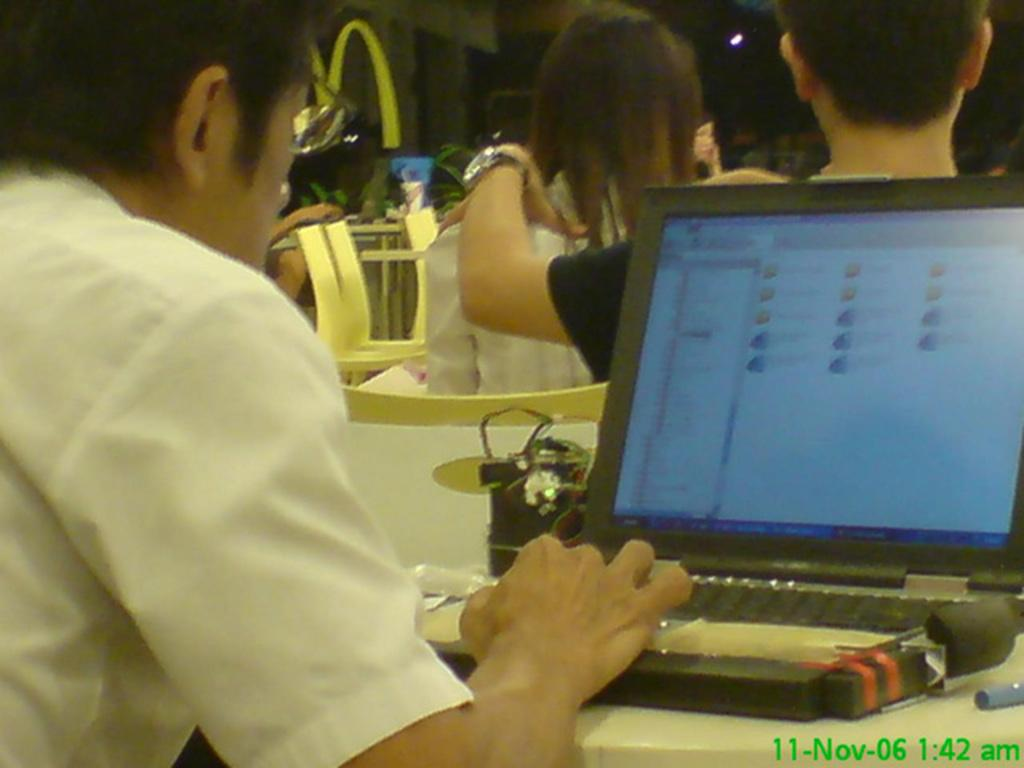What is the person in the image doing? The person is operating a laptop in the image. Can you describe the person's attire? The person is wearing a white shirt. What accessory is the person wearing? The person is wearing spectacles. Are there any other people visible in the image? Yes, there are other people visible in the image. What type of substance is the person using to enhance the laptop's performance in the image? There is no indication in the image that the person is using any substance to enhance the laptop's performance. 